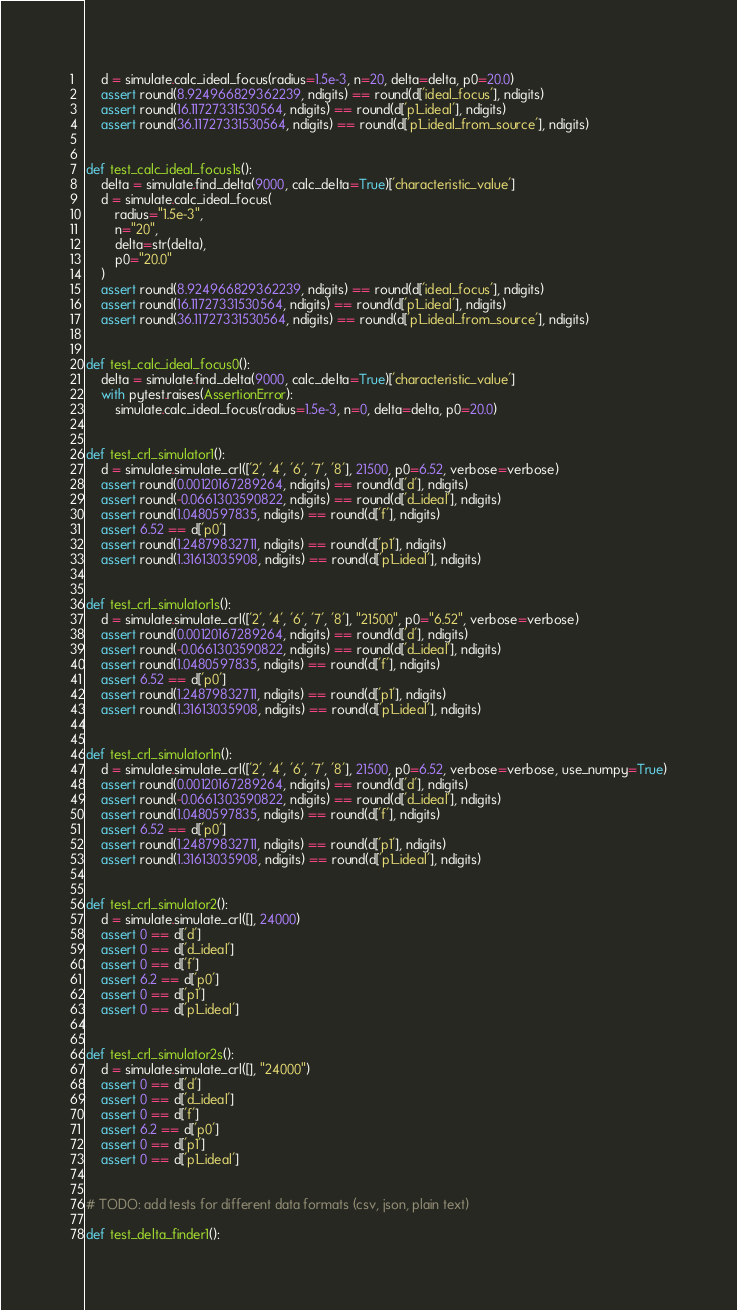Convert code to text. <code><loc_0><loc_0><loc_500><loc_500><_Python_>    d = simulate.calc_ideal_focus(radius=1.5e-3, n=20, delta=delta, p0=20.0)
    assert round(8.924966829362239, ndigits) == round(d['ideal_focus'], ndigits)
    assert round(16.11727331530564, ndigits) == round(d['p1_ideal'], ndigits)
    assert round(36.11727331530564, ndigits) == round(d['p1_ideal_from_source'], ndigits)


def test_calc_ideal_focus1s():
    delta = simulate.find_delta(9000, calc_delta=True)['characteristic_value']
    d = simulate.calc_ideal_focus(
        radius="1.5e-3",
        n="20",
        delta=str(delta),
        p0="20.0"
    )
    assert round(8.924966829362239, ndigits) == round(d['ideal_focus'], ndigits)
    assert round(16.11727331530564, ndigits) == round(d['p1_ideal'], ndigits)
    assert round(36.11727331530564, ndigits) == round(d['p1_ideal_from_source'], ndigits)


def test_calc_ideal_focus0():
    delta = simulate.find_delta(9000, calc_delta=True)['characteristic_value']
    with pytest.raises(AssertionError):
        simulate.calc_ideal_focus(radius=1.5e-3, n=0, delta=delta, p0=20.0)


def test_crl_simulator1():
    d = simulate.simulate_crl(['2', '4', '6', '7', '8'], 21500, p0=6.52, verbose=verbose)
    assert round(0.00120167289264, ndigits) == round(d['d'], ndigits)
    assert round(-0.0661303590822, ndigits) == round(d['d_ideal'], ndigits)
    assert round(1.0480597835, ndigits) == round(d['f'], ndigits)
    assert 6.52 == d['p0']
    assert round(1.24879832711, ndigits) == round(d['p1'], ndigits)
    assert round(1.31613035908, ndigits) == round(d['p1_ideal'], ndigits)


def test_crl_simulator1s():
    d = simulate.simulate_crl(['2', '4', '6', '7', '8'], "21500", p0="6.52", verbose=verbose)
    assert round(0.00120167289264, ndigits) == round(d['d'], ndigits)
    assert round(-0.0661303590822, ndigits) == round(d['d_ideal'], ndigits)
    assert round(1.0480597835, ndigits) == round(d['f'], ndigits)
    assert 6.52 == d['p0']
    assert round(1.24879832711, ndigits) == round(d['p1'], ndigits)
    assert round(1.31613035908, ndigits) == round(d['p1_ideal'], ndigits)


def test_crl_simulator1n():
    d = simulate.simulate_crl(['2', '4', '6', '7', '8'], 21500, p0=6.52, verbose=verbose, use_numpy=True)
    assert round(0.00120167289264, ndigits) == round(d['d'], ndigits)
    assert round(-0.0661303590822, ndigits) == round(d['d_ideal'], ndigits)
    assert round(1.0480597835, ndigits) == round(d['f'], ndigits)
    assert 6.52 == d['p0']
    assert round(1.24879832711, ndigits) == round(d['p1'], ndigits)
    assert round(1.31613035908, ndigits) == round(d['p1_ideal'], ndigits)


def test_crl_simulator2():
    d = simulate.simulate_crl([], 24000)
    assert 0 == d['d']
    assert 0 == d['d_ideal']
    assert 0 == d['f']
    assert 6.2 == d['p0']
    assert 0 == d['p1']
    assert 0 == d['p1_ideal']


def test_crl_simulator2s():
    d = simulate.simulate_crl([], "24000")
    assert 0 == d['d']
    assert 0 == d['d_ideal']
    assert 0 == d['f']
    assert 6.2 == d['p0']
    assert 0 == d['p1']
    assert 0 == d['p1_ideal']


# TODO: add tests for different data formats (csv, json, plain text)

def test_delta_finder1():</code> 